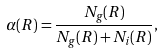<formula> <loc_0><loc_0><loc_500><loc_500>\alpha ( R ) = \frac { N _ { g } ( R ) } { N _ { g } ( R ) + N _ { i } ( R ) } ,</formula> 